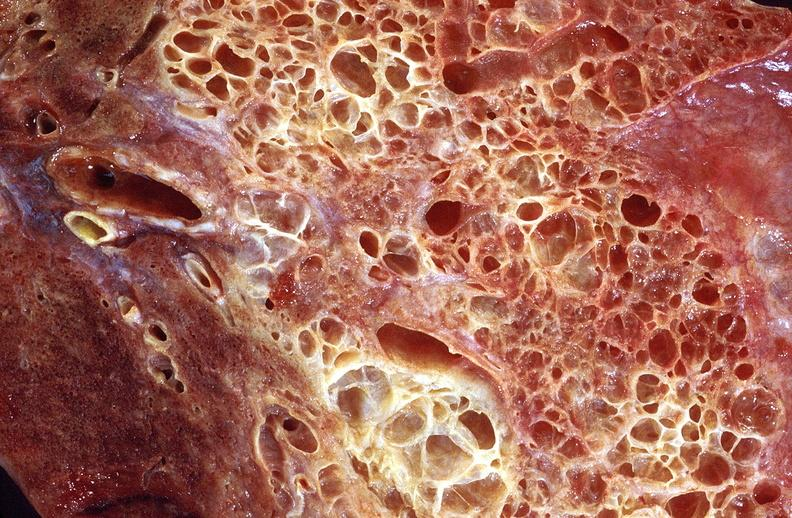what does this image show?
Answer the question using a single word or phrase. Lung fibrosis 